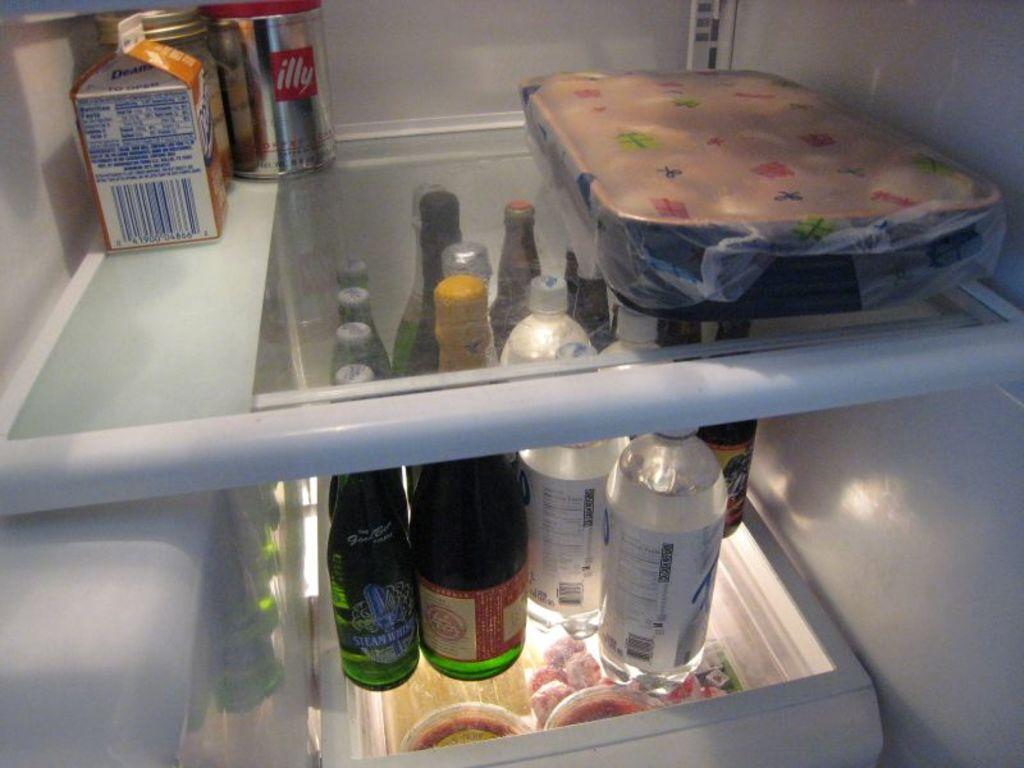Provide a one-sentence caption for the provided image. The inside of a fridge with a "illy" aluminum can on the top shelf. 